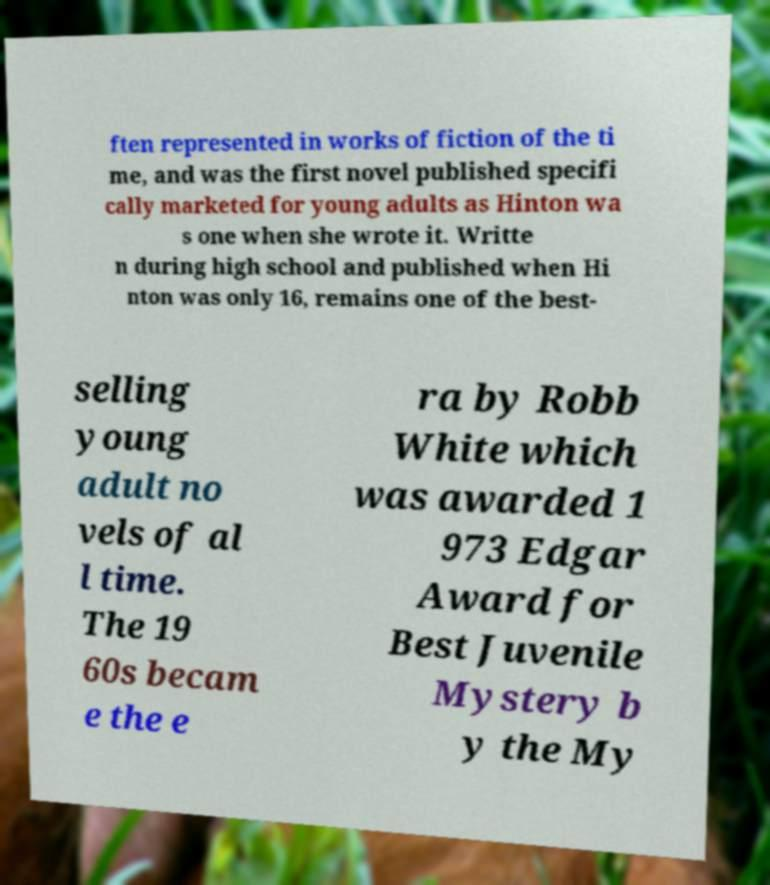Could you extract and type out the text from this image? ften represented in works of fiction of the ti me, and was the first novel published specifi cally marketed for young adults as Hinton wa s one when she wrote it. Writte n during high school and published when Hi nton was only 16, remains one of the best- selling young adult no vels of al l time. The 19 60s becam e the e ra by Robb White which was awarded 1 973 Edgar Award for Best Juvenile Mystery b y the My 